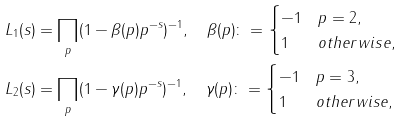<formula> <loc_0><loc_0><loc_500><loc_500>& L _ { 1 } ( s ) = \prod _ { p } ( 1 - \beta ( p ) p ^ { - s } ) ^ { - 1 } , \quad \beta ( p ) \colon = \begin{cases} - 1 & p = 2 , \\ 1 & o t h e r w i s e , \end{cases} \\ & L _ { 2 } ( s ) = \prod _ { p } ( 1 - \gamma ( p ) p ^ { - s } ) ^ { - 1 } , \quad \gamma ( p ) \colon = \begin{cases} - 1 & p = 3 , \\ 1 & o t h e r w i s e , \end{cases}</formula> 